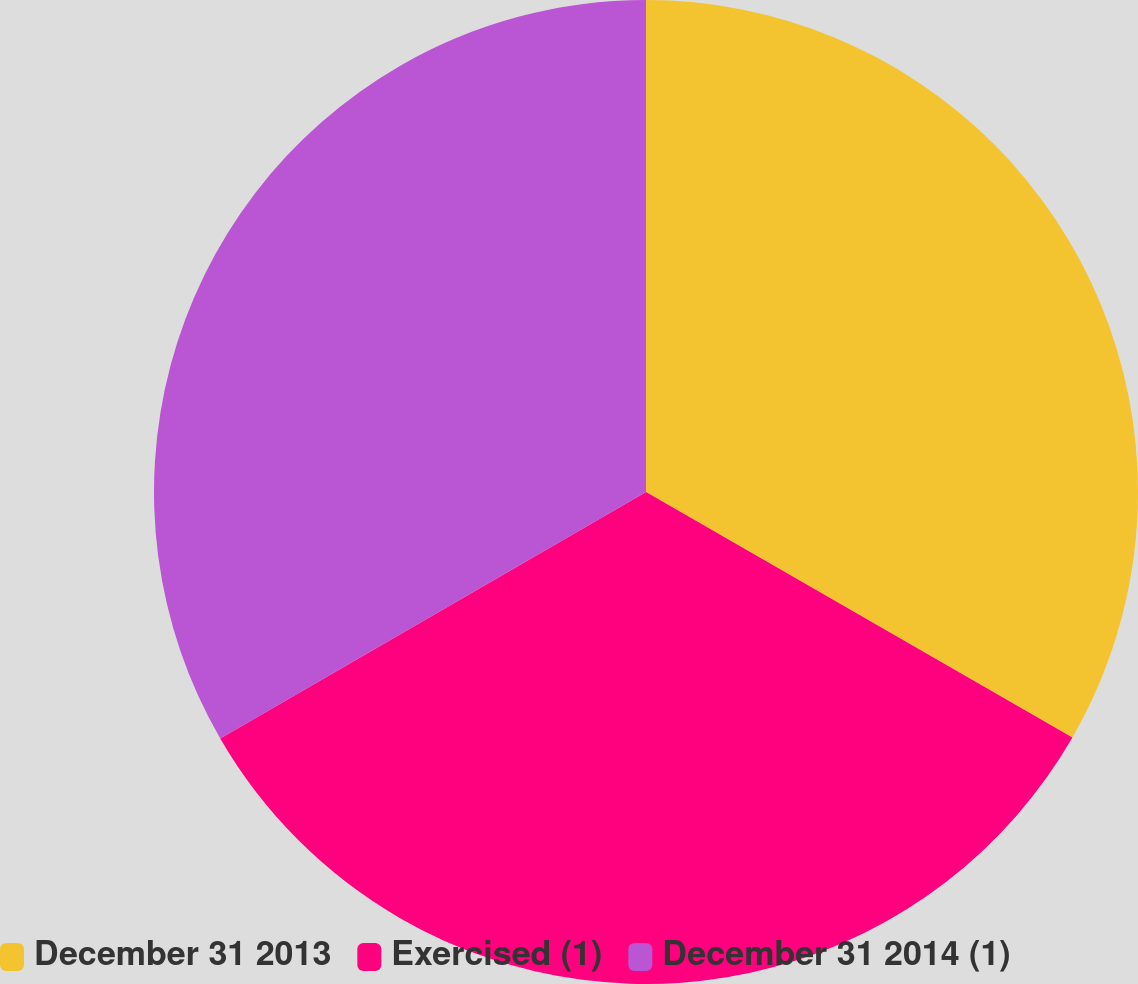Convert chart to OTSL. <chart><loc_0><loc_0><loc_500><loc_500><pie_chart><fcel>December 31 2013<fcel>Exercised (1)<fcel>December 31 2014 (1)<nl><fcel>33.31%<fcel>33.33%<fcel>33.35%<nl></chart> 